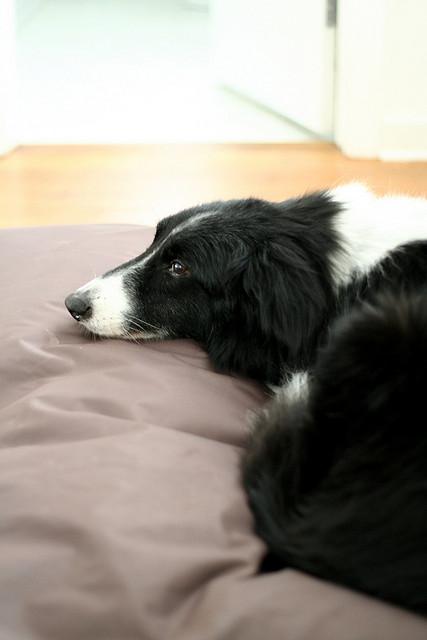Is the animal resting or running?
Give a very brief answer. Resting. What color is the dog?
Give a very brief answer. Black and white. What animal is this?
Write a very short answer. Dog. 